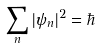Convert formula to latex. <formula><loc_0><loc_0><loc_500><loc_500>\sum _ { n } | \psi _ { n } | ^ { 2 } = \hbar</formula> 